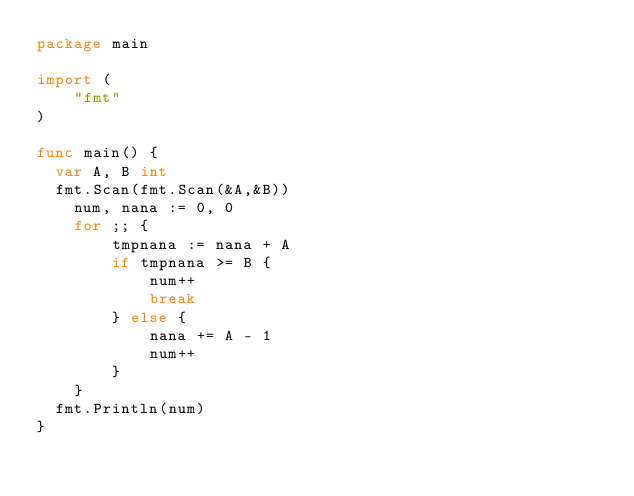<code> <loc_0><loc_0><loc_500><loc_500><_Go_>package main

import (
	"fmt"
)

func main() {
  var A, B int
  fmt.Scan(fmt.Scan(&A,&B))
	num, nana := 0, 0
	for ;; {
		tmpnana := nana + A
		if tmpnana >= B {
			num++
			break
		} else {
			nana += A - 1
			num++
		}
	} 
  fmt.Println(num)
}
</code> 